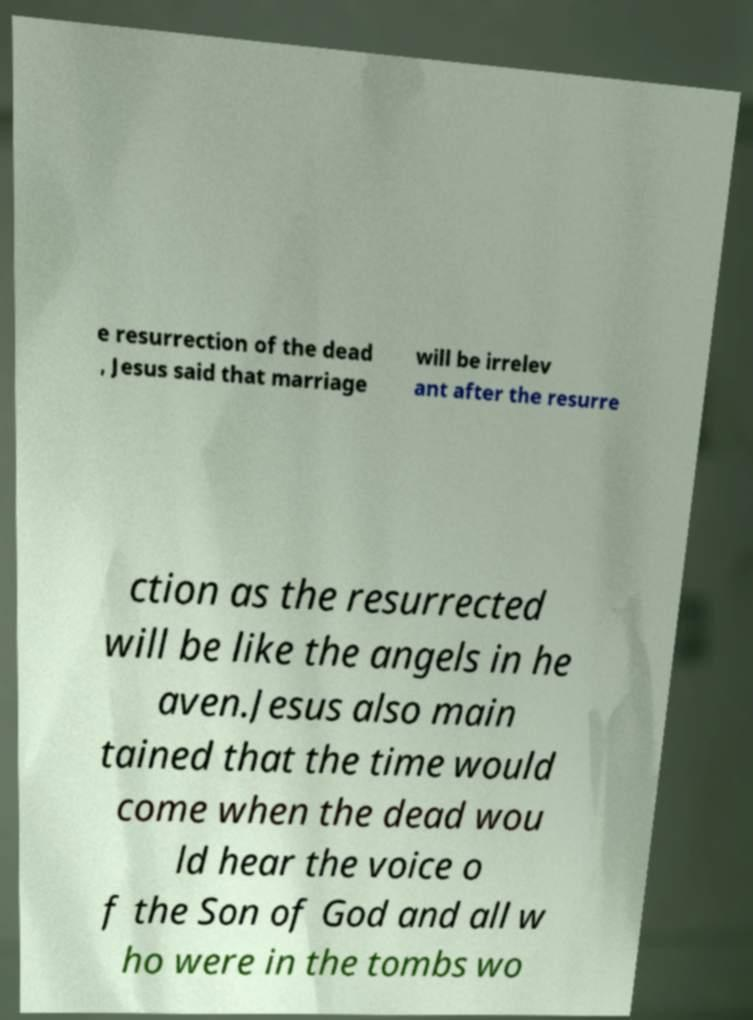I need the written content from this picture converted into text. Can you do that? e resurrection of the dead , Jesus said that marriage will be irrelev ant after the resurre ction as the resurrected will be like the angels in he aven.Jesus also main tained that the time would come when the dead wou ld hear the voice o f the Son of God and all w ho were in the tombs wo 